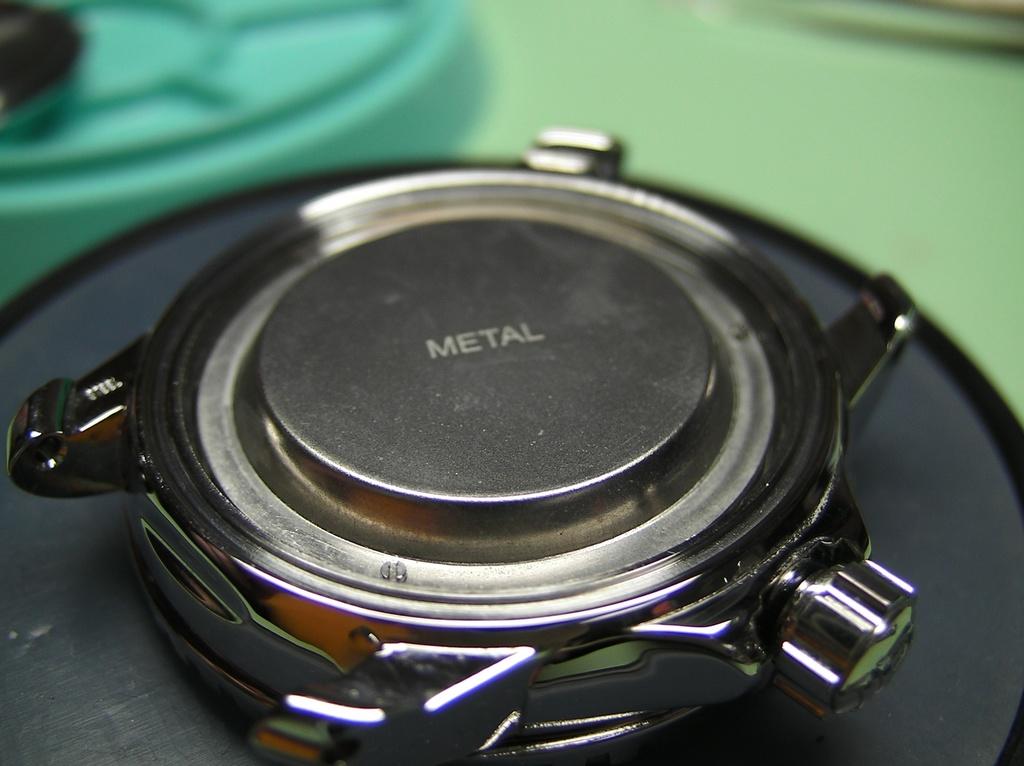What kind of material is this bolt made of?
Provide a short and direct response. Metal. 